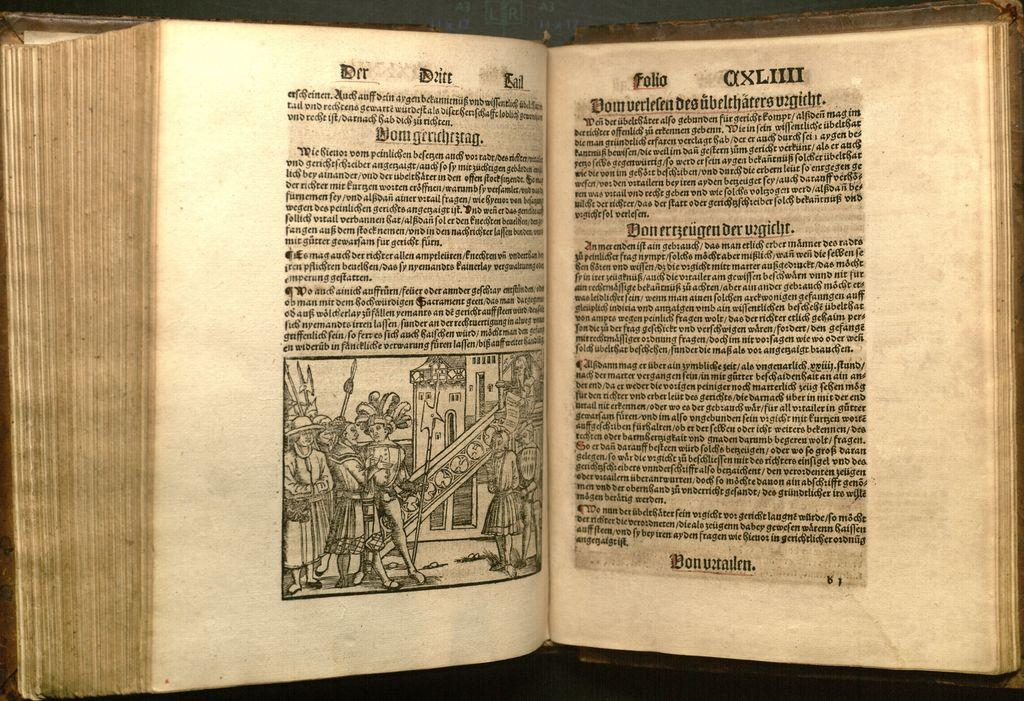<image>
Relay a brief, clear account of the picture shown. an open book where one of the pages says 'folio domverlelen' on it 